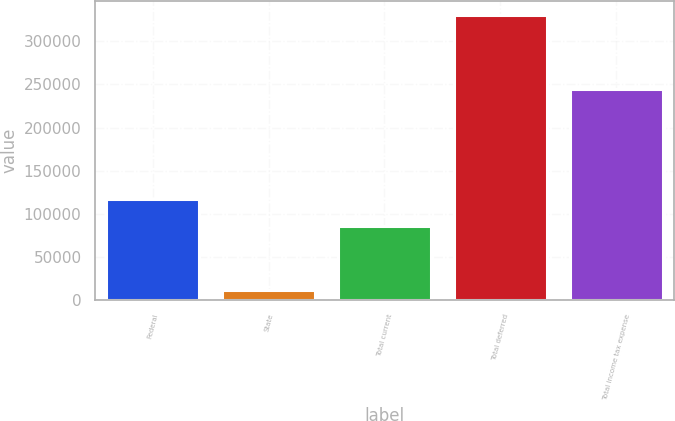Convert chart. <chart><loc_0><loc_0><loc_500><loc_500><bar_chart><fcel>Federal<fcel>State<fcel>Total current<fcel>Total deferred<fcel>Total income tax expense<nl><fcel>117414<fcel>11983<fcel>85548<fcel>330643<fcel>245095<nl></chart> 